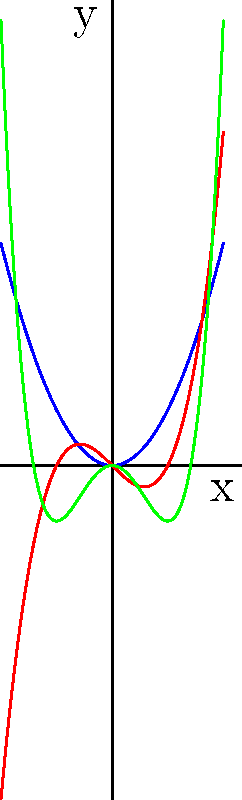Analyze the graphs of the quadratic, cubic, and quartic polynomials shown. How does the degree of each polynomial relate to the maximum number of turning points (local extrema) in its graph? Formulate a general rule for this relationship. Let's analyze each polynomial graph step-by-step:

1. Quadratic polynomial (blue):
   - Degree: 2
   - Number of turning points: 1

2. Cubic polynomial (red):
   - Degree: 3
   - Number of turning points: 2

3. Quartic polynomial (green):
   - Degree: 4
   - Number of turning points: 3

Observing the pattern:
- Degree 2 → 1 turning point
- Degree 3 → 2 turning points
- Degree 4 → 3 turning points

We can formulate a general rule:
For a polynomial of degree $n$, the maximum number of turning points is $n-1$.

This rule can be explained mathematically:
1. A turning point occurs where the first derivative of the polynomial is zero.
2. The first derivative of a polynomial of degree $n$ is a polynomial of degree $n-1$.
3. By the Fundamental Theorem of Algebra, a polynomial of degree $n-1$ can have at most $n-1$ real roots.
4. Therefore, the original polynomial of degree $n$ can have at most $n-1$ turning points.
Answer: Maximum number of turning points = degree of polynomial - 1 